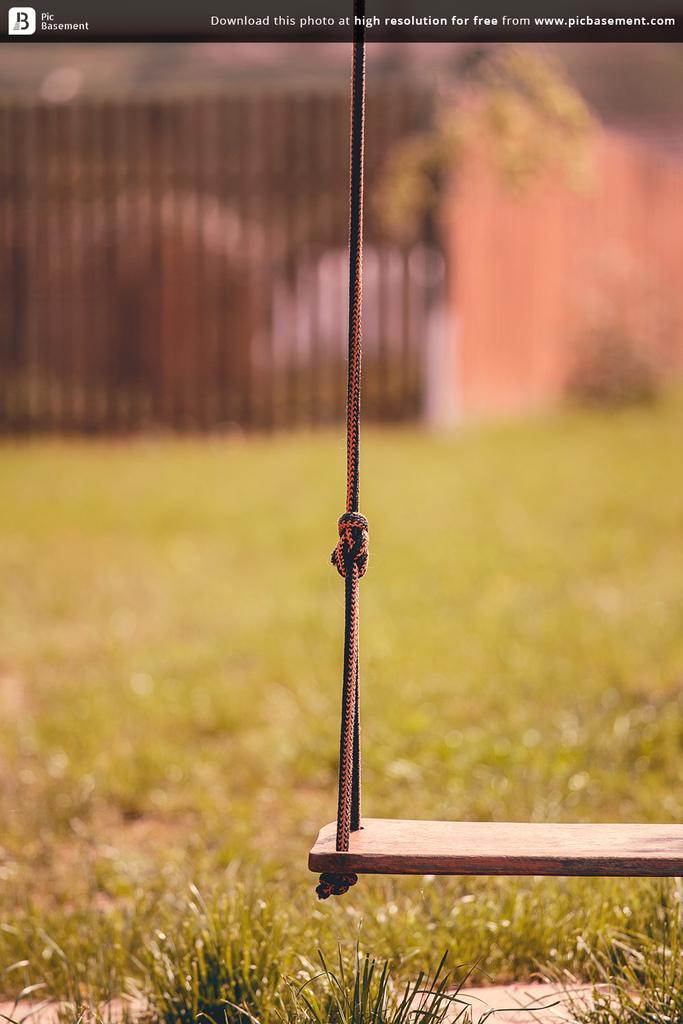What is the main object in the image? There is a swing in the image. What type of surface is visible beneath the swing? Grass is visible on the ground. What can be seen in the background of the image? There is a fencing and a wall in the background. What color is the ink on the swing in the image? There is no ink present on the swing in the image. How does the salt affect the movement of the swing in the image? There is no salt present in the image, so it cannot affect the movement of the swing. 